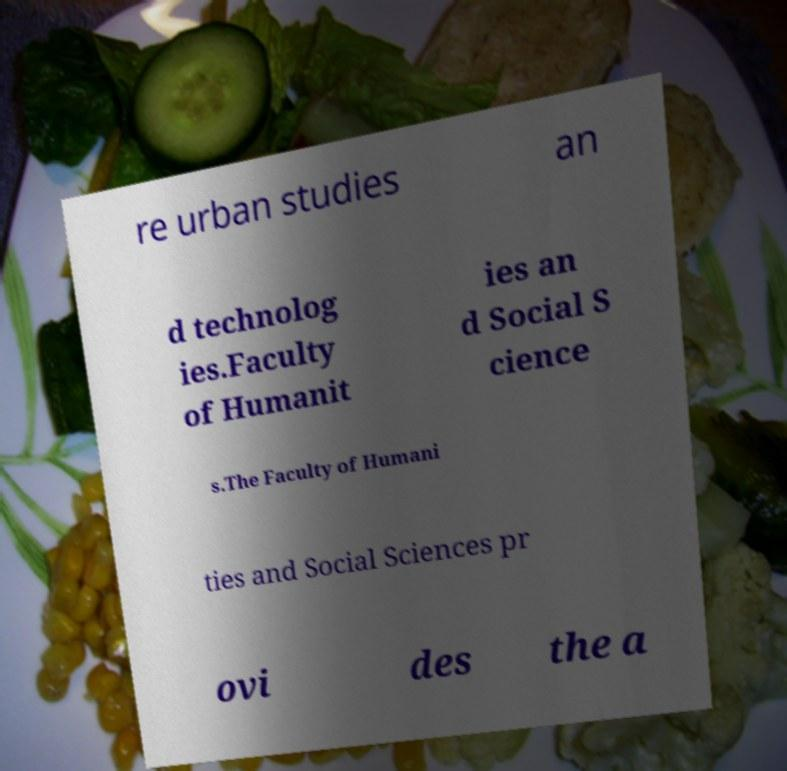What messages or text are displayed in this image? I need them in a readable, typed format. re urban studies an d technolog ies.Faculty of Humanit ies an d Social S cience s.The Faculty of Humani ties and Social Sciences pr ovi des the a 